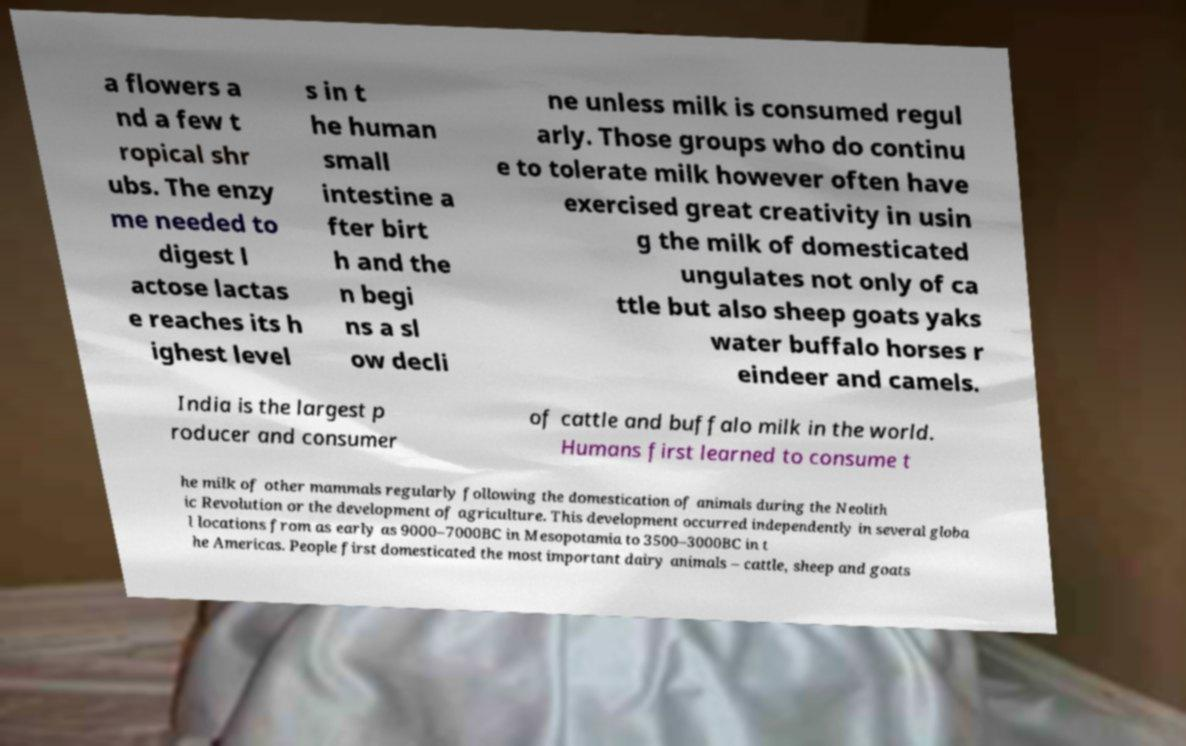What messages or text are displayed in this image? I need them in a readable, typed format. a flowers a nd a few t ropical shr ubs. The enzy me needed to digest l actose lactas e reaches its h ighest level s in t he human small intestine a fter birt h and the n begi ns a sl ow decli ne unless milk is consumed regul arly. Those groups who do continu e to tolerate milk however often have exercised great creativity in usin g the milk of domesticated ungulates not only of ca ttle but also sheep goats yaks water buffalo horses r eindeer and camels. India is the largest p roducer and consumer of cattle and buffalo milk in the world. Humans first learned to consume t he milk of other mammals regularly following the domestication of animals during the Neolith ic Revolution or the development of agriculture. This development occurred independently in several globa l locations from as early as 9000–7000BC in Mesopotamia to 3500–3000BC in t he Americas. People first domesticated the most important dairy animals – cattle, sheep and goats 